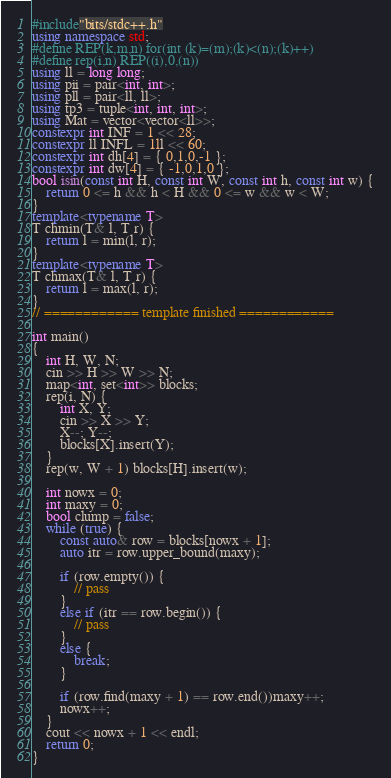Convert code to text. <code><loc_0><loc_0><loc_500><loc_500><_C++_>#include"bits/stdc++.h"
using namespace std;
#define REP(k,m,n) for(int (k)=(m);(k)<(n);(k)++)
#define rep(i,n) REP((i),0,(n))
using ll = long long;
using pii = pair<int, int>;
using pll = pair<ll, ll>;
using tp3 = tuple<int, int, int>;
using Mat = vector<vector<ll>>;
constexpr int INF = 1 << 28;
constexpr ll INFL = 1ll << 60;
constexpr int dh[4] = { 0,1,0,-1 };
constexpr int dw[4] = { -1,0,1,0 };
bool isin(const int H, const int W, const int h, const int w) {
    return 0 <= h && h < H && 0 <= w && w < W;
}
template<typename T>
T chmin(T& l, T r) {
    return l = min(l, r);
}
template<typename T>
T chmax(T& l, T r) {
    return l = max(l, r);
}
// ============ template finished ============

int main()
{
    int H, W, N;
    cin >> H >> W >> N;
    map<int, set<int>> blocks;
    rep(i, N) {
        int X, Y;
        cin >> X >> Y;
        X--; Y--;
        blocks[X].insert(Y);
    }
    rep(w, W + 1) blocks[H].insert(w);

    int nowx = 0;
    int maxy = 0;
    bool clump = false;
    while (true) {
        const auto& row = blocks[nowx + 1];
        auto itr = row.upper_bound(maxy);

        if (row.empty()) {
            // pass
        }
        else if (itr == row.begin()) {
            // pass
        }
        else {
            break;
        }

        if (row.find(maxy + 1) == row.end())maxy++;
        nowx++;
    }
    cout << nowx + 1 << endl;
    return 0;
}
</code> 